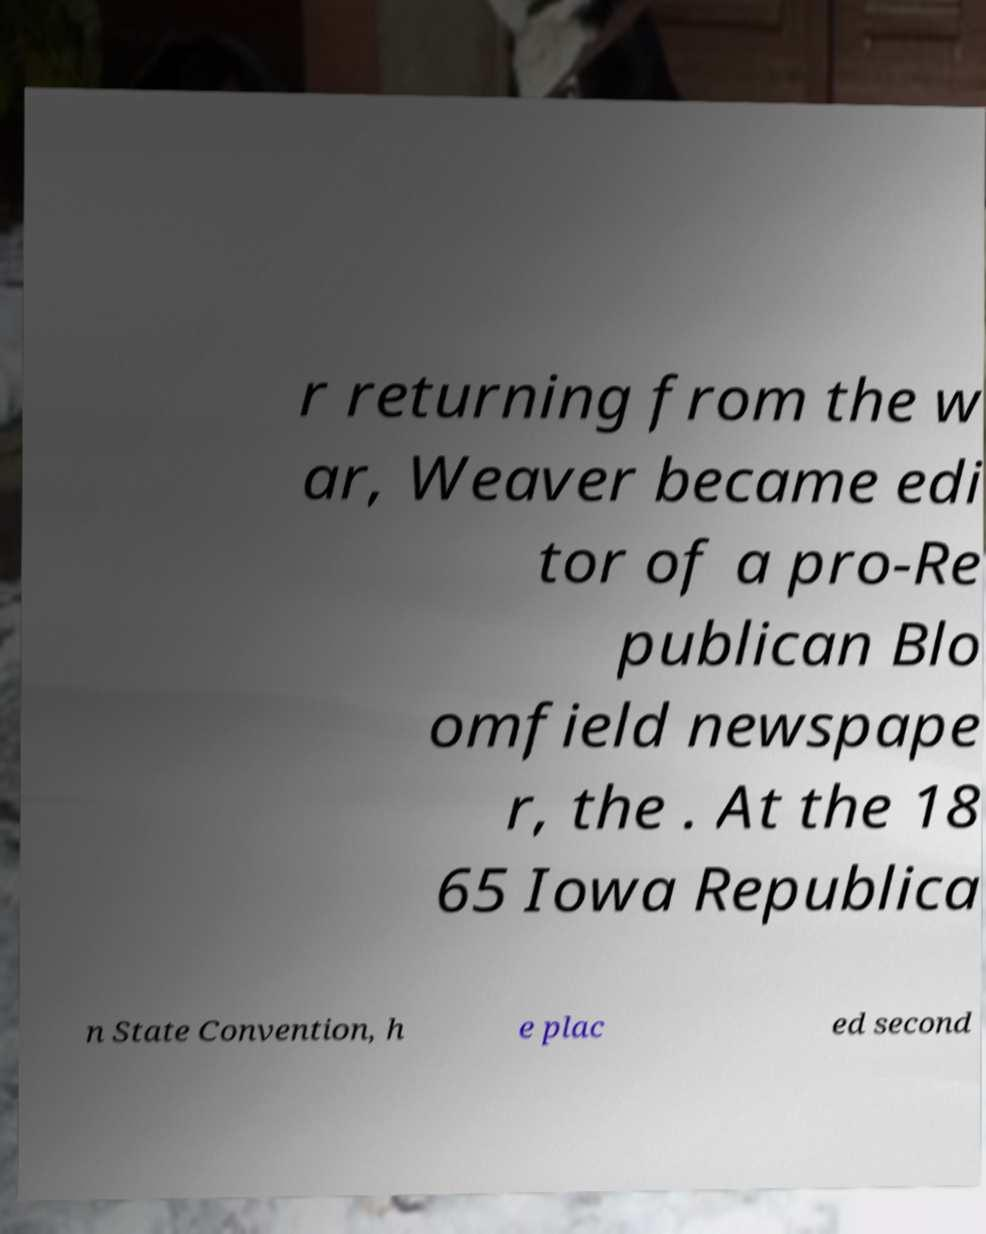Please identify and transcribe the text found in this image. r returning from the w ar, Weaver became edi tor of a pro-Re publican Blo omfield newspape r, the . At the 18 65 Iowa Republica n State Convention, h e plac ed second 